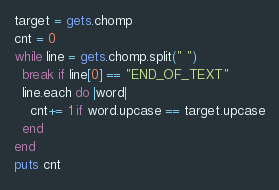<code> <loc_0><loc_0><loc_500><loc_500><_Ruby_>target = gets.chomp
cnt = 0
while line = gets.chomp.split(" ")
  break if line[0] == "END_OF_TEXT"
  line.each do |word|
    cnt+= 1 if word.upcase == target.upcase
  end
end
puts cnt</code> 